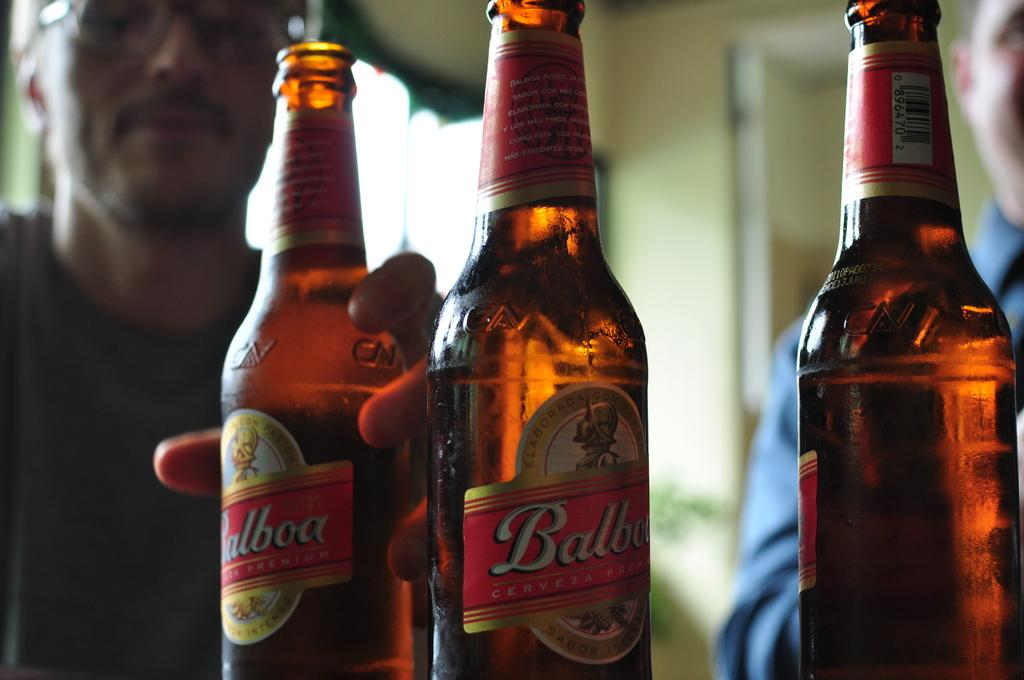<image>
Relay a brief, clear account of the picture shown. A man is reaching for a bottle of Balboa sitting in front of him. 